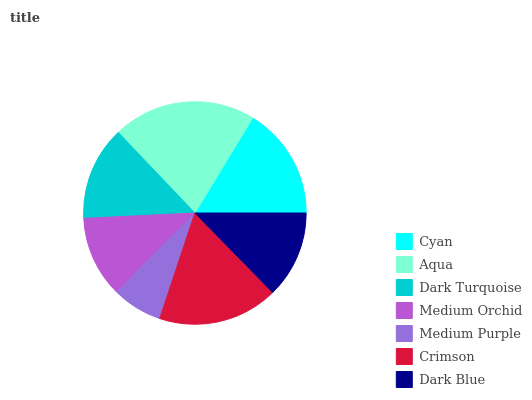Is Medium Purple the minimum?
Answer yes or no. Yes. Is Aqua the maximum?
Answer yes or no. Yes. Is Dark Turquoise the minimum?
Answer yes or no. No. Is Dark Turquoise the maximum?
Answer yes or no. No. Is Aqua greater than Dark Turquoise?
Answer yes or no. Yes. Is Dark Turquoise less than Aqua?
Answer yes or no. Yes. Is Dark Turquoise greater than Aqua?
Answer yes or no. No. Is Aqua less than Dark Turquoise?
Answer yes or no. No. Is Dark Turquoise the high median?
Answer yes or no. Yes. Is Dark Turquoise the low median?
Answer yes or no. Yes. Is Medium Orchid the high median?
Answer yes or no. No. Is Crimson the low median?
Answer yes or no. No. 